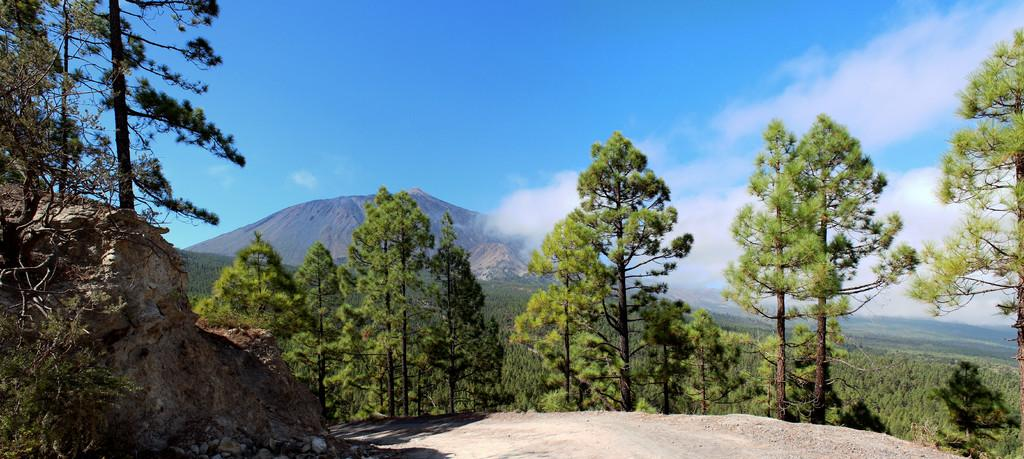What type of natural features can be seen in the image? There are trees, rocks, mud, and mountains in the image. What is the condition of the sky in the image? The sky is cloudy in the image. Where is the basket located in the image? There is no basket present in the image. What type of tool is being used to dig in the mud in the image? There is no tool being used to dig in the mud in the image, as there is no mud being dug in the image, or tool present in the image. 